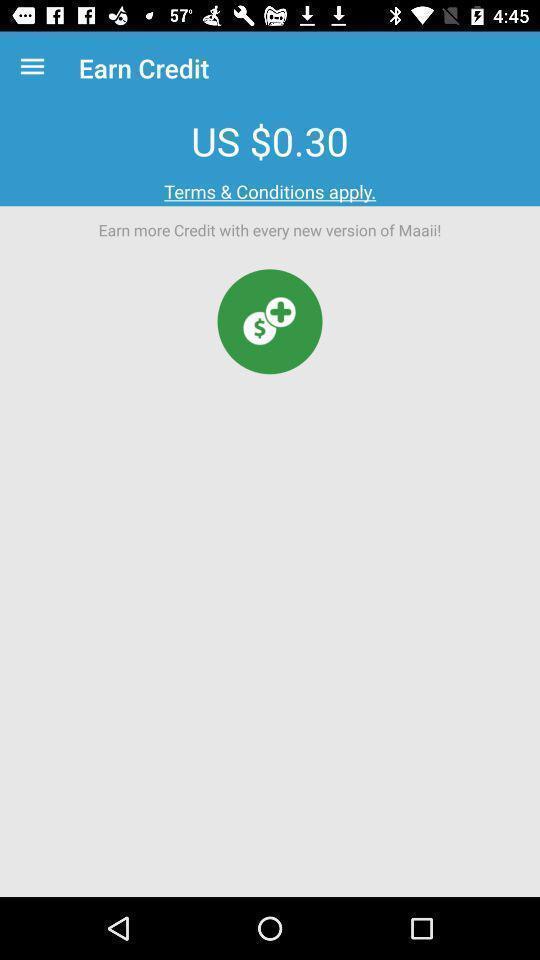What is the overall content of this screenshot? Page displaying information of credits. 